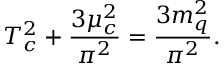<formula> <loc_0><loc_0><loc_500><loc_500>T _ { c } ^ { 2 } + \frac { 3 \mu _ { c } ^ { 2 } } { \pi ^ { 2 } } = \frac { 3 m _ { q } ^ { 2 } } { \pi ^ { 2 } } .</formula> 